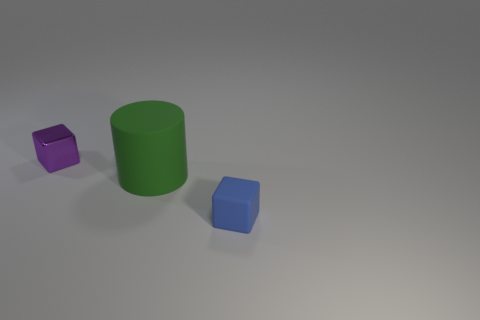Are there any other things that have the same material as the tiny purple thing?
Give a very brief answer. No. There is a tiny cube that is in front of the tiny block that is behind the tiny blue cube; how many small matte objects are on the right side of it?
Offer a terse response. 0. There is a cube that is in front of the small purple block; what color is it?
Offer a terse response. Blue. What number of metal cubes are behind the tiny block that is left of the blue thing?
Make the answer very short. 0. What is the shape of the large thing?
Your answer should be very brief. Cylinder. What is the shape of the big green thing that is the same material as the tiny blue cube?
Ensure brevity in your answer.  Cylinder. Do the small object on the right side of the large green matte cylinder and the tiny purple object have the same shape?
Make the answer very short. Yes. The matte thing that is to the left of the blue block has what shape?
Provide a short and direct response. Cylinder. How many other cubes are the same size as the blue block?
Make the answer very short. 1. The rubber block has what color?
Provide a succinct answer. Blue. 